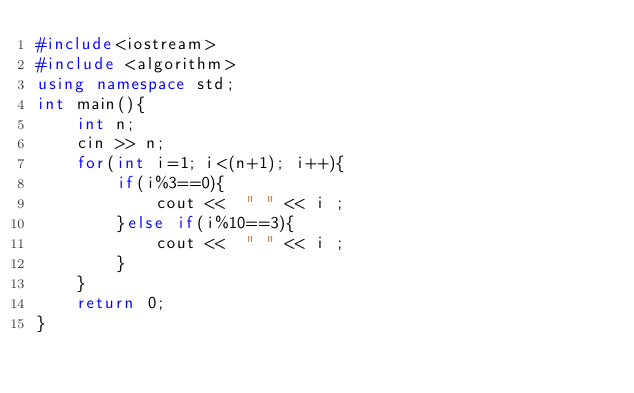Convert code to text. <code><loc_0><loc_0><loc_500><loc_500><_C++_>#include<iostream>
#include <algorithm>
using namespace std;
int main(){
    int n;
	cin >> n;
    for(int i=1; i<(n+1); i++){
		if(i%3==0){
			cout <<  " " << i ;
		}else if(i%10==3){
			cout <<  " " << i ;
		}
	}
    return 0;
}</code> 